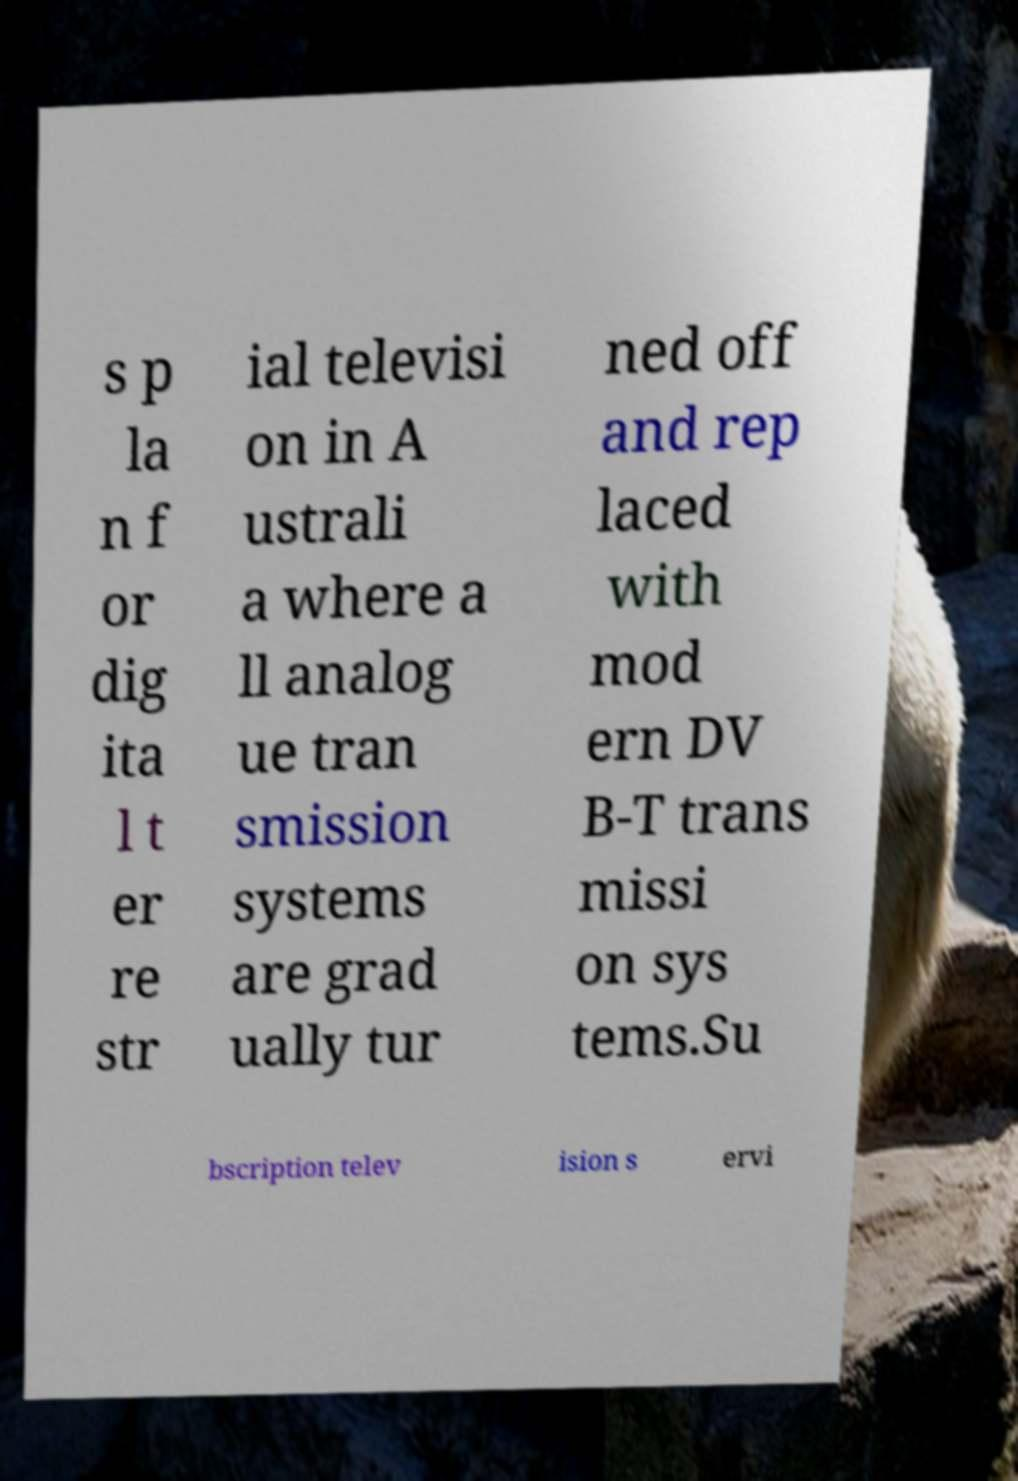For documentation purposes, I need the text within this image transcribed. Could you provide that? s p la n f or dig ita l t er re str ial televisi on in A ustrali a where a ll analog ue tran smission systems are grad ually tur ned off and rep laced with mod ern DV B-T trans missi on sys tems.Su bscription telev ision s ervi 